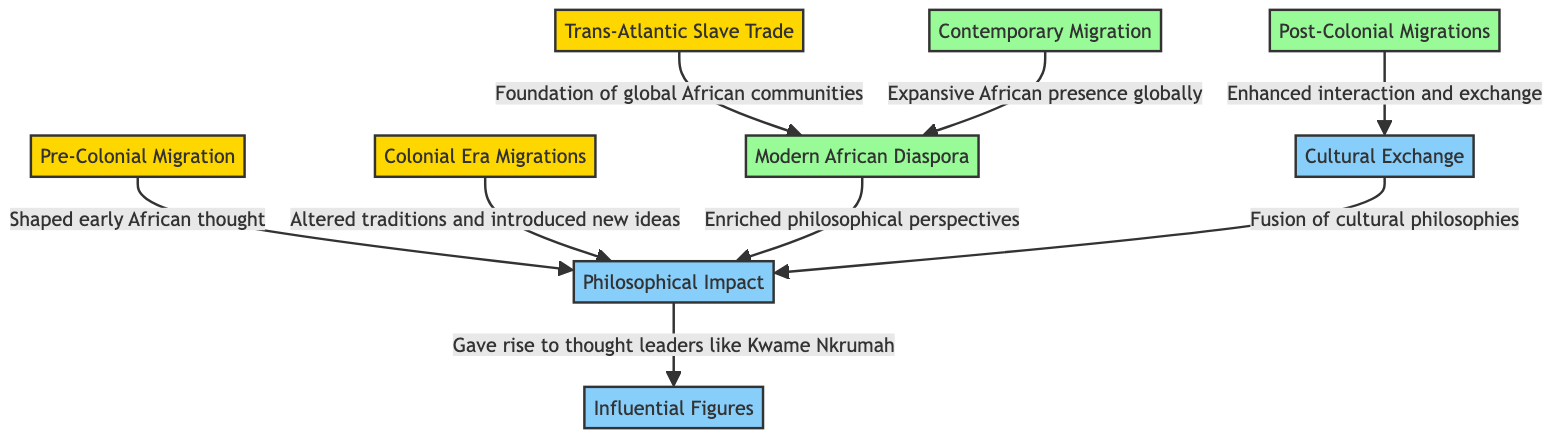What is the first migration type mentioned? The diagram indicates that the first migration type is "Pre-Colonial Migration." This is found at the top of the flowchart, indicating its significance as the starting point.
Answer: Pre-Colonial Migration How many contemporary migration types are represented in the diagram? In the diagram, there are three contemporary migration types: "Post-Colonial Migrations," "Contemporary Migration," and "Modern African Diaspora." These are listed towards the bottom of the chart.
Answer: 3 What philosophical impact resulted from the Trans-Atlantic Slave Trade? The Trans-Atlantic Slave Trade is linked to the "Foundation of global African communities." This phrase in the diagram explicitly connects the historical migration to its philosophical implications.
Answer: Foundation of global African communities Which contemporary migration influenced cultural exchange? The diagram shows that "Post-Colonial Migrations" enhanced interaction and exchange. This means that this specific migration type directly contributed to cultural exchanges, as stated in the connection to "Cultural Exchange."
Answer: Post-Colonial Migrations Who is one influential figure mentioned as a result of philosophical impact? The diagram specifies "Kwame Nkrumah" as a thought leader that emerged from the philosophical impact. This is noted as a direct flow from the "Philosophical Impact" node.
Answer: Kwame Nkrumah What is the relationship between modern diaspora and philosophical perspectives? The relationship depicted in the diagram states that the "Modern African Diaspora" enriched philosophical perspectives. This indicates that the diaspora directly contributed to the evolution of philosophical thought.
Answer: Enriched philosophical perspectives What altered traditions according to the diagram? The "Colonial Era Migrations" are shown to have "Altered traditions and introduced new ideas." This phrase connects directly to the impact of that particular period on cultural transformation.
Answer: Altered traditions and introduced new ideas How does contemporary migration influence the modern diaspora? The diagram states that "Contemporary Migration" leads to an "Expansive African presence globally," which directly shapes and supports the concept of the "Modern African Diaspora." This illustrates the linkage of contemporary actions to diaspora growth.
Answer: Expansive African presence globally What type of impact results in a fusion of cultural philosophies? According to the diagram, "Cultural Exchange" leads to a "Fusion of cultural philosophies." This means that exchanges across cultures result in the blending of various philosophical thought patterns, showcasing the interconnectedness of ideas.
Answer: Fusion of cultural philosophies 